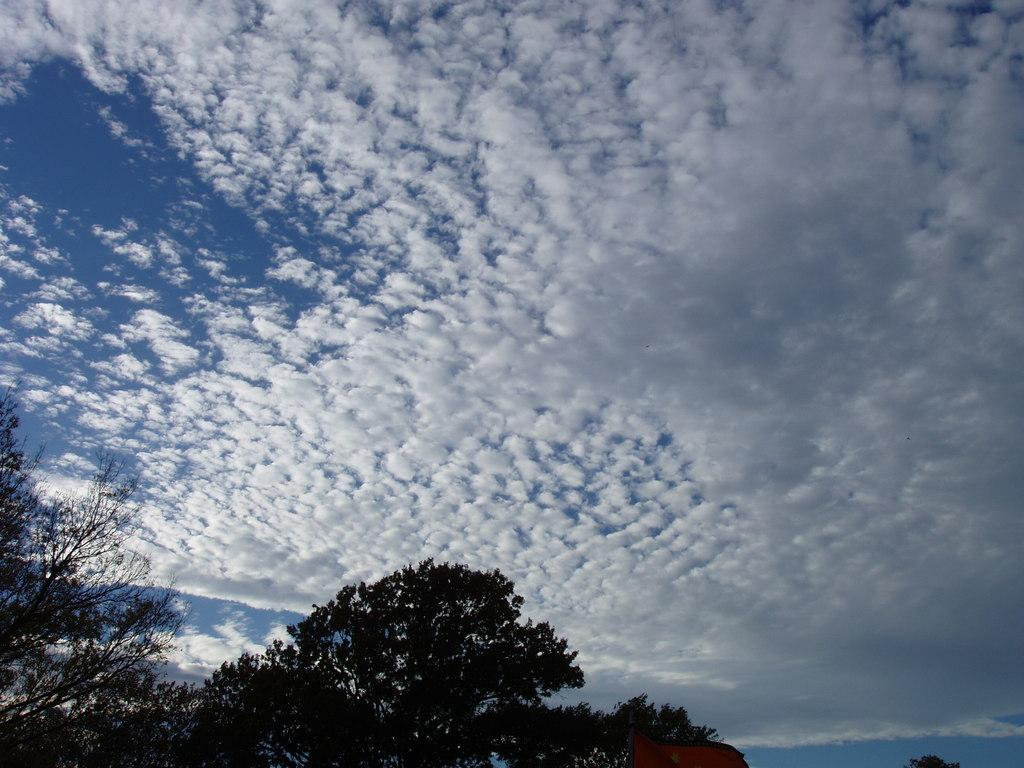What type of vegetation is present in the image? There is a group of trees in the image. How would you describe the sky in the image? The sky in the image appears cloudy. Can you identify any objects at the bottom of the image? There is an object at the bottom of the image. What time of day is it in the image, and how many spiders are crawling on the trees? The time of day is not mentioned in the image, and there are no spiders visible on the trees. What type of gardening tool is being used in the image? There is no gardening tool present in the image. 